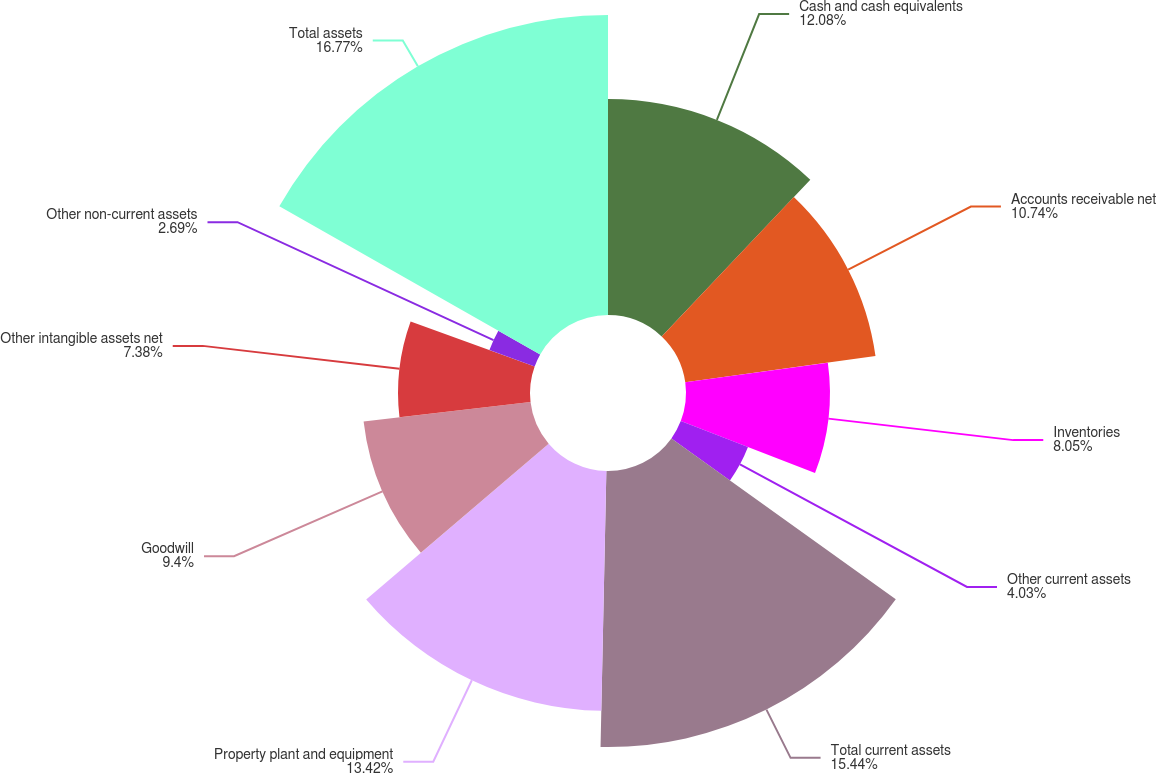Convert chart. <chart><loc_0><loc_0><loc_500><loc_500><pie_chart><fcel>Cash and cash equivalents<fcel>Accounts receivable net<fcel>Inventories<fcel>Other current assets<fcel>Total current assets<fcel>Property plant and equipment<fcel>Goodwill<fcel>Other intangible assets net<fcel>Other non-current assets<fcel>Total assets<nl><fcel>12.08%<fcel>10.74%<fcel>8.05%<fcel>4.03%<fcel>15.44%<fcel>13.42%<fcel>9.4%<fcel>7.38%<fcel>2.69%<fcel>16.78%<nl></chart> 